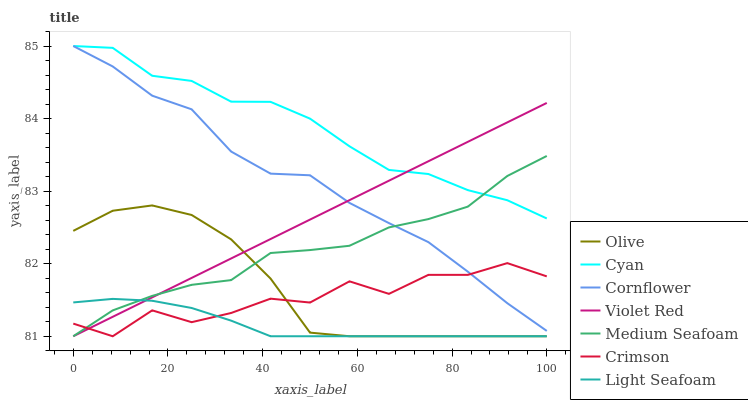Does Light Seafoam have the minimum area under the curve?
Answer yes or no. Yes. Does Cyan have the maximum area under the curve?
Answer yes or no. Yes. Does Violet Red have the minimum area under the curve?
Answer yes or no. No. Does Violet Red have the maximum area under the curve?
Answer yes or no. No. Is Violet Red the smoothest?
Answer yes or no. Yes. Is Crimson the roughest?
Answer yes or no. Yes. Is Crimson the smoothest?
Answer yes or no. No. Is Violet Red the roughest?
Answer yes or no. No. Does Violet Red have the lowest value?
Answer yes or no. Yes. Does Cyan have the lowest value?
Answer yes or no. No. Does Cyan have the highest value?
Answer yes or no. Yes. Does Violet Red have the highest value?
Answer yes or no. No. Is Light Seafoam less than Cyan?
Answer yes or no. Yes. Is Cornflower greater than Light Seafoam?
Answer yes or no. Yes. Does Violet Red intersect Light Seafoam?
Answer yes or no. Yes. Is Violet Red less than Light Seafoam?
Answer yes or no. No. Is Violet Red greater than Light Seafoam?
Answer yes or no. No. Does Light Seafoam intersect Cyan?
Answer yes or no. No. 